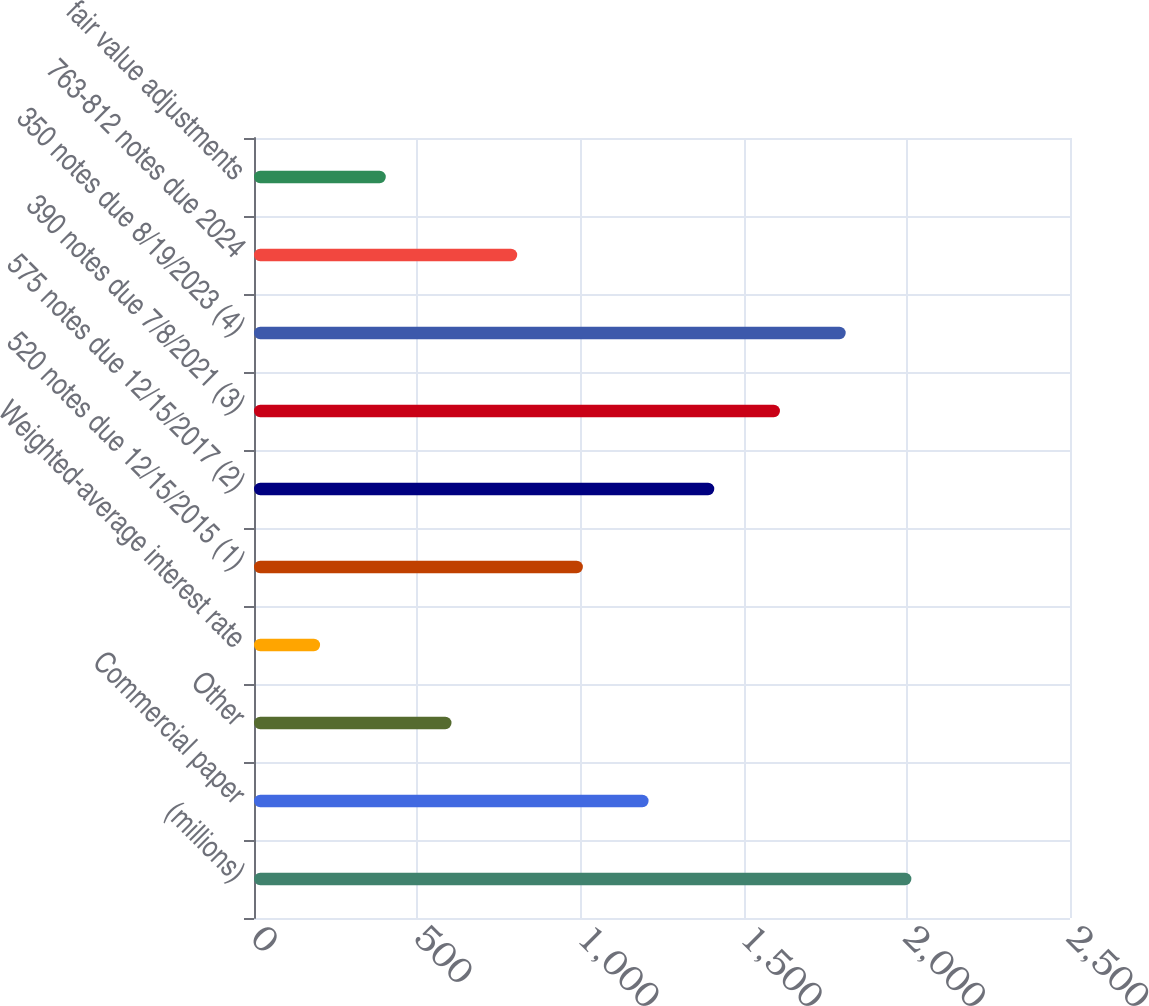Convert chart. <chart><loc_0><loc_0><loc_500><loc_500><bar_chart><fcel>(millions)<fcel>Commercial paper<fcel>Other<fcel>Weighted-average interest rate<fcel>520 notes due 12/15/2015 (1)<fcel>575 notes due 12/15/2017 (2)<fcel>390 notes due 7/8/2021 (3)<fcel>350 notes due 8/19/2023 (4)<fcel>763-812 notes due 2024<fcel>fair value adjustments<nl><fcel>2014<fcel>1208.88<fcel>605.04<fcel>202.48<fcel>1007.6<fcel>1410.16<fcel>1611.44<fcel>1812.72<fcel>806.32<fcel>403.76<nl></chart> 